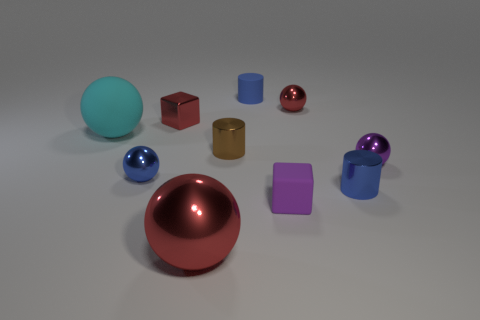What size is the ball that is the same color as the big metal object?
Provide a succinct answer. Small. What is the material of the cylinder behind the small cube that is behind the big rubber object?
Make the answer very short. Rubber. How many objects are tiny red metallic balls or cubes that are right of the large cyan sphere?
Your response must be concise. 3. The blue cylinder that is made of the same material as the brown object is what size?
Your answer should be compact. Small. How many brown objects are big rubber balls or metallic balls?
Keep it short and to the point. 0. There is a large shiny thing that is the same color as the metallic cube; what shape is it?
Your answer should be very brief. Sphere. Are there any other things that are made of the same material as the purple cube?
Your answer should be compact. Yes. There is a small matte object that is in front of the small metal block; does it have the same shape as the large object that is behind the small purple matte block?
Keep it short and to the point. No. How many small shiny spheres are there?
Give a very brief answer. 3. What is the shape of the blue object that is the same material as the large cyan ball?
Your answer should be compact. Cylinder. 